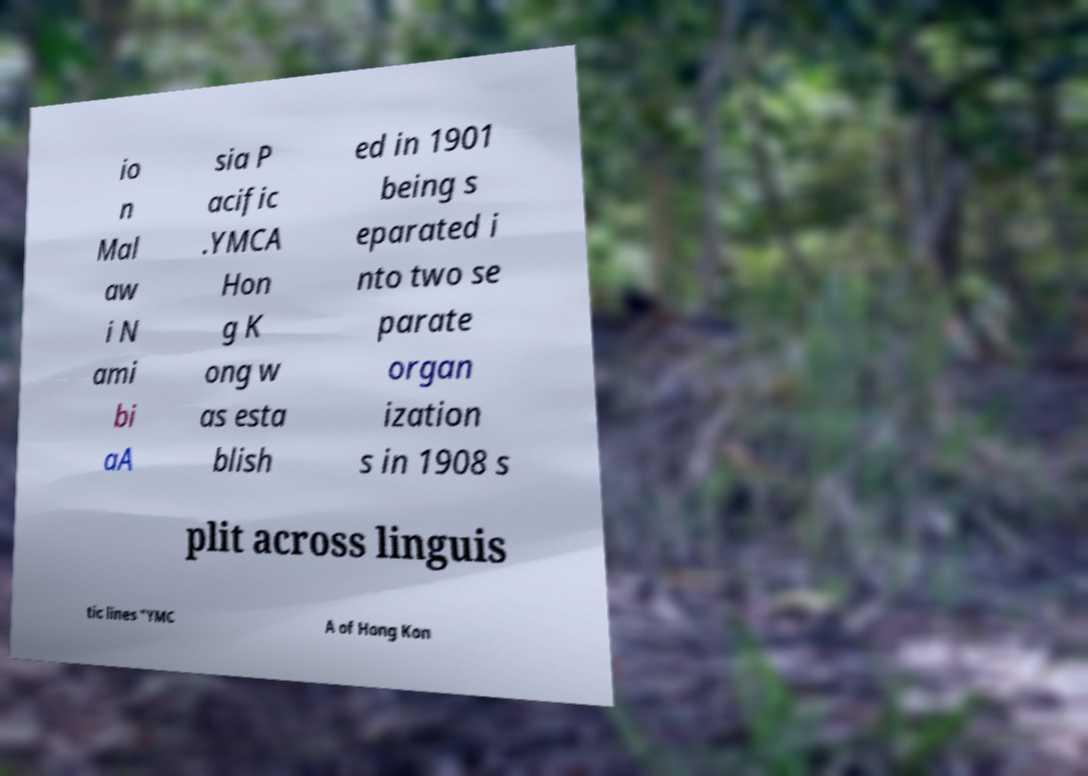For documentation purposes, I need the text within this image transcribed. Could you provide that? io n Mal aw i N ami bi aA sia P acific .YMCA Hon g K ong w as esta blish ed in 1901 being s eparated i nto two se parate organ ization s in 1908 s plit across linguis tic lines "YMC A of Hong Kon 